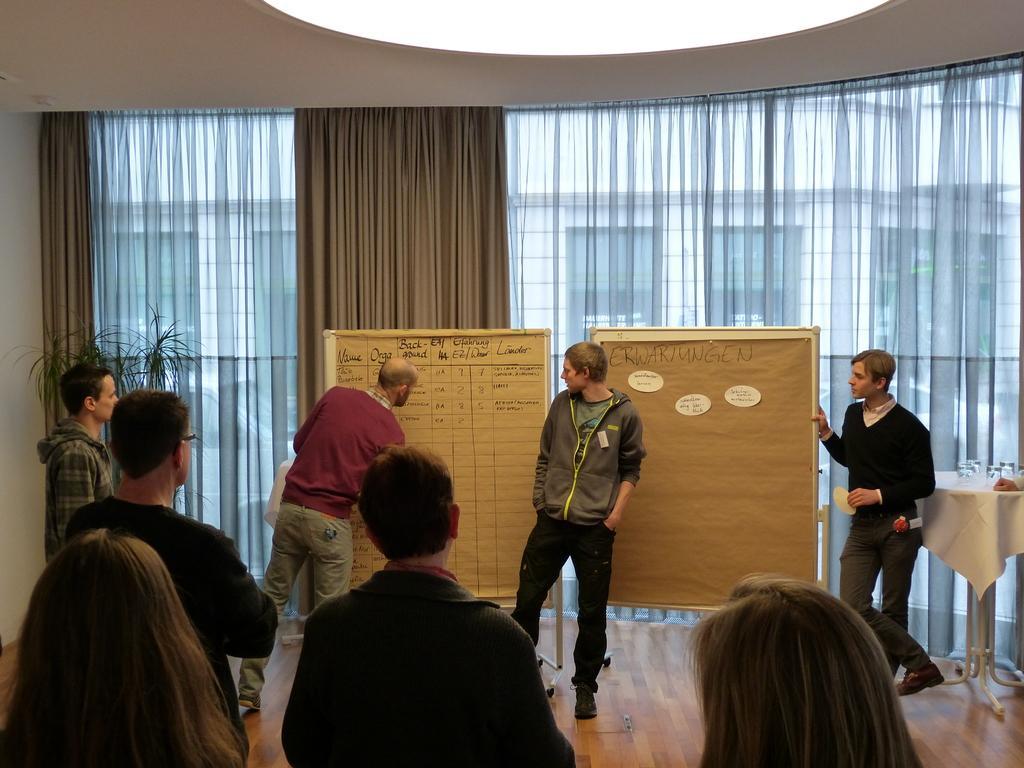Describe this image in one or two sentences. As we can see in the image there is a wall, curtains, few people standing here and there. There is a board and a table. On table there are glasses. 